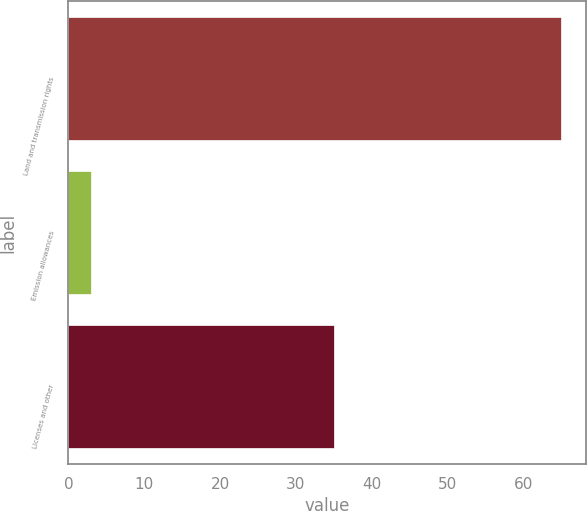Convert chart. <chart><loc_0><loc_0><loc_500><loc_500><bar_chart><fcel>Land and transmission rights<fcel>Emission allowances<fcel>Licenses and other<nl><fcel>65<fcel>3<fcel>35<nl></chart> 